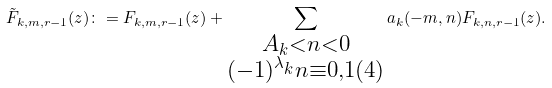<formula> <loc_0><loc_0><loc_500><loc_500>\tilde { F } _ { k , m , r - 1 } ( z ) \colon = F _ { k , m , r - 1 } ( z ) + \sum _ { \substack { A _ { k } < n < 0 \\ ( - 1 ) ^ { \lambda _ { k } } n \equiv 0 , 1 ( 4 ) } } a _ { k } ( - m , n ) F _ { k , n , r - 1 } ( z ) .</formula> 